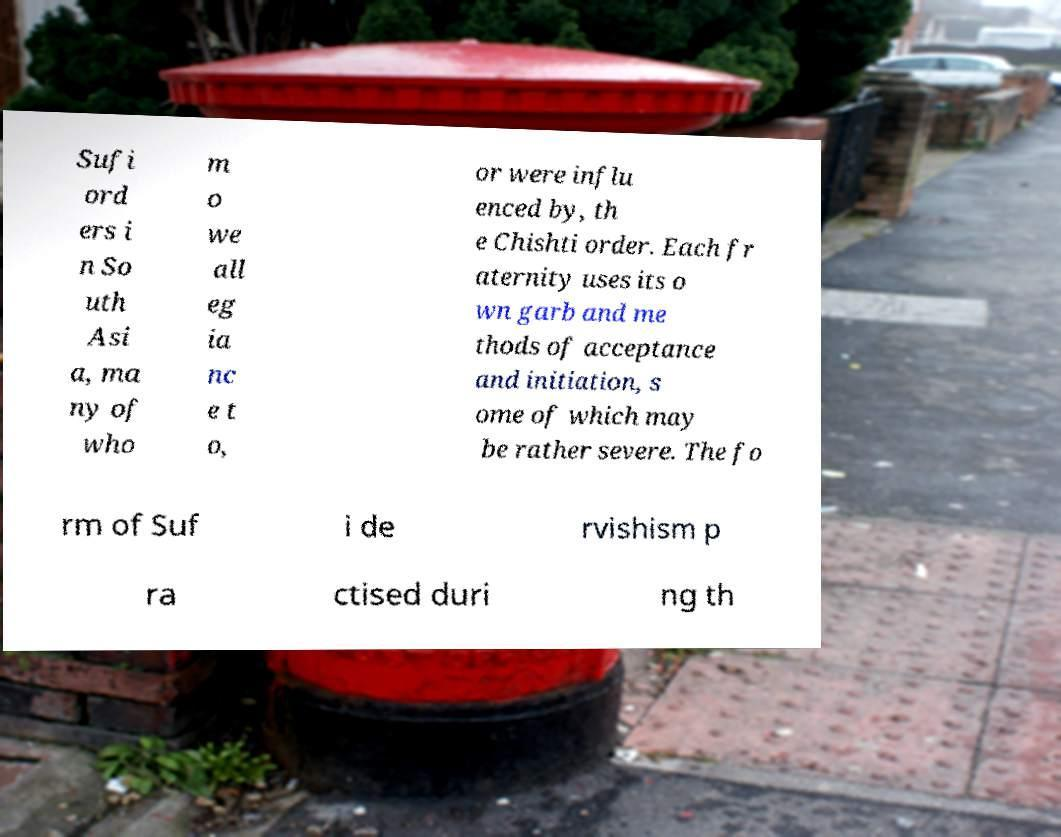Could you extract and type out the text from this image? Sufi ord ers i n So uth Asi a, ma ny of who m o we all eg ia nc e t o, or were influ enced by, th e Chishti order. Each fr aternity uses its o wn garb and me thods of acceptance and initiation, s ome of which may be rather severe. The fo rm of Suf i de rvishism p ra ctised duri ng th 